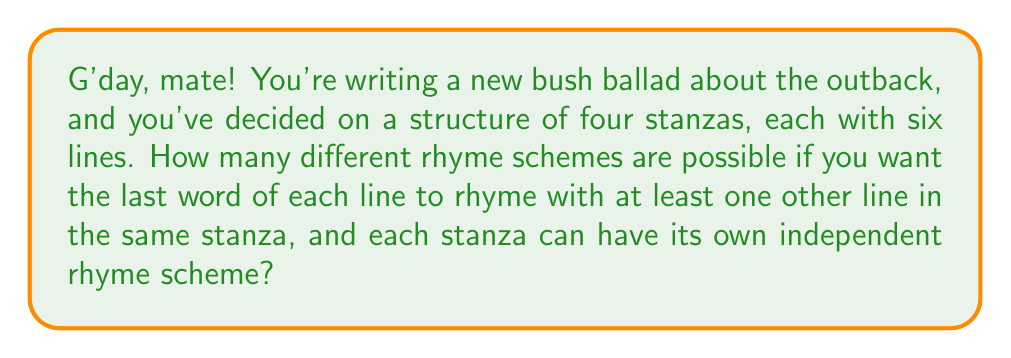Can you answer this question? Let's approach this step-by-step, fair dinkum:

1) First, we need to consider how many ways we can rhyme 6 lines within a single stanza:

   a) All 6 lines could rhyme: 1 way
   b) 5 lines could rhyme, 1 different: $\binom{6}{5} = 6$ ways
   c) 4 lines could rhyme, 2 different: $\binom{6}{4} = 15$ ways
   d) 3 lines could rhyme, 3 different: $\binom{6}{3} = 20$ ways
   e) Two sets of 3 rhyming lines: $\frac{1}{2}\binom{6}{3} = 10$ ways
   f) Two sets of 2 rhyming lines, 2 different: $\frac{1}{2}\binom{6}{2}\binom{4}{2} = 45$ ways

2) The total number of possible rhyme schemes for a single stanza is the sum of these:
   
   $1 + 6 + 15 + 20 + 10 + 45 = 97$

3) Now, since each stanza can have its own independent rhyme scheme, and we have 4 stanzas, we need to raise this to the power of 4:

   $97^4 = 88,529,281$

Therefore, there are 88,529,281 possible rhyme schemes for your bush ballad, mate!
Answer: $97^4 = 88,529,281$ 